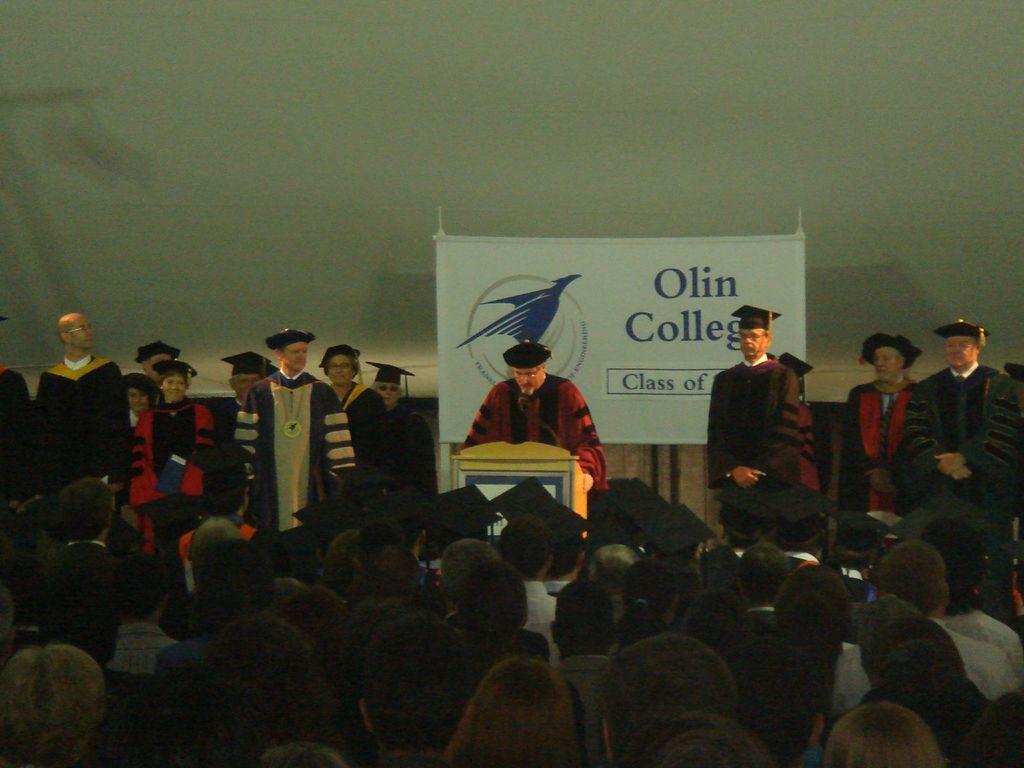Describe this image in one or two sentences. In this image I can see a group of people standing and facing towards the back at the bottom of the image. I can see some people standing on the stage in the center of the image. The person standing on the stage in the center of the image is talking in a mike. I can see a banner behind him with some text. I can see a wall behind the banner. 